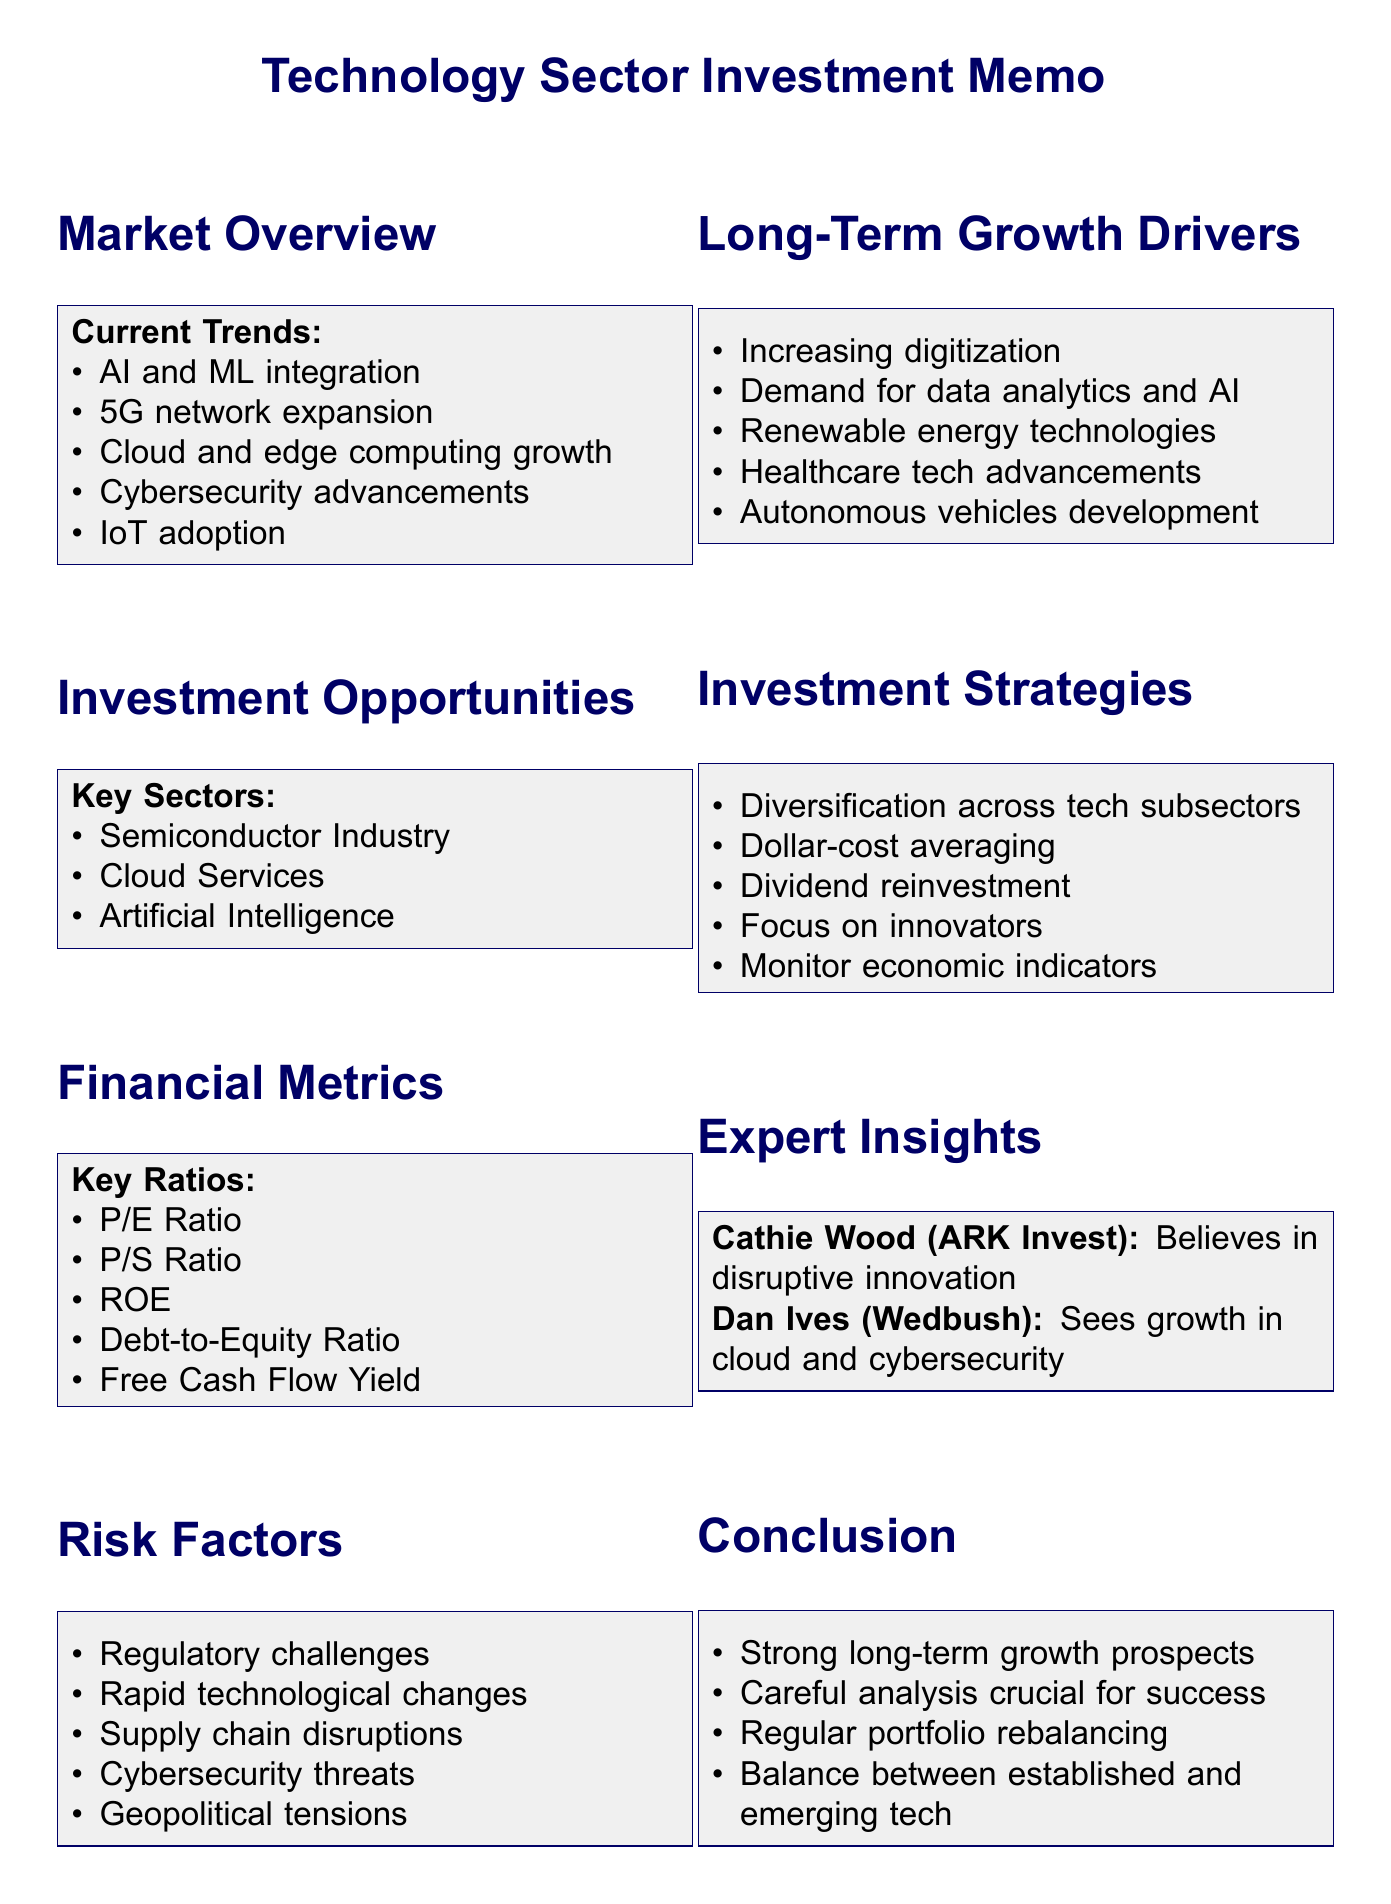What are the current trends in the technology sector? The current trends listed in the document include AI and ML integration, 5G network expansion, cloud and edge computing growth, cybersecurity advancements, and IoT adoption.
Answer: AI and ML integration, 5G network expansion, cloud and edge computing growth, cybersecurity advancements, IoT adoption Which companies are mentioned as key players in the technology sector? The document lists key players such as Apple Inc., Microsoft Corporation, Amazon.com Inc., Alphabet Inc. (Google), and NVIDIA Corporation.
Answer: Apple Inc., Microsoft Corporation, Amazon.com Inc., Alphabet Inc. (Google), NVIDIA Corporation What sector is identified as having strong growth prospects related to cloud services? The investment opportunity section specifies the cloud services sector with companies like Amazon Web Services, Microsoft Azure, and Google Cloud Platform.
Answer: Cloud Services Which financial metric helps assess company valuation? The document outlines key ratios, including Price-to-Earnings (P/E) Ratio, which helps in assessing company valuation.
Answer: Price-to-Earnings (P/E) Ratio What is a potential risk factor mentioned that could affect investment in the technology sector? The document lists risk factors such as regulatory challenges, rapid technological changes, and supply chain disruptions, which can impact investments.
Answer: Regulatory challenges What investment strategy involves spreading investments across different tech subsectors? The document outlines diversification as an investment strategy to minimize risk by spreading investments across different tech subsectors.
Answer: Diversification According to expert insights, which sector is seen as having strong growth potential? The expert insights section mentions strong growth potential in cloud computing and cybersecurity sectors as per Dan Ives.
Answer: Cloud computing and cybersecurity What should investors monitor as part of their investment strategies? The document suggests monitoring economic indicators like interest rates, inflation, and GDP growth for informed decision-making.
Answer: Economic indicators What is a long-term growth driver mentioned in the memo? The memo mentions increasing digitization across all sectors as one of the long-term growth drivers.
Answer: Increasing digitization 